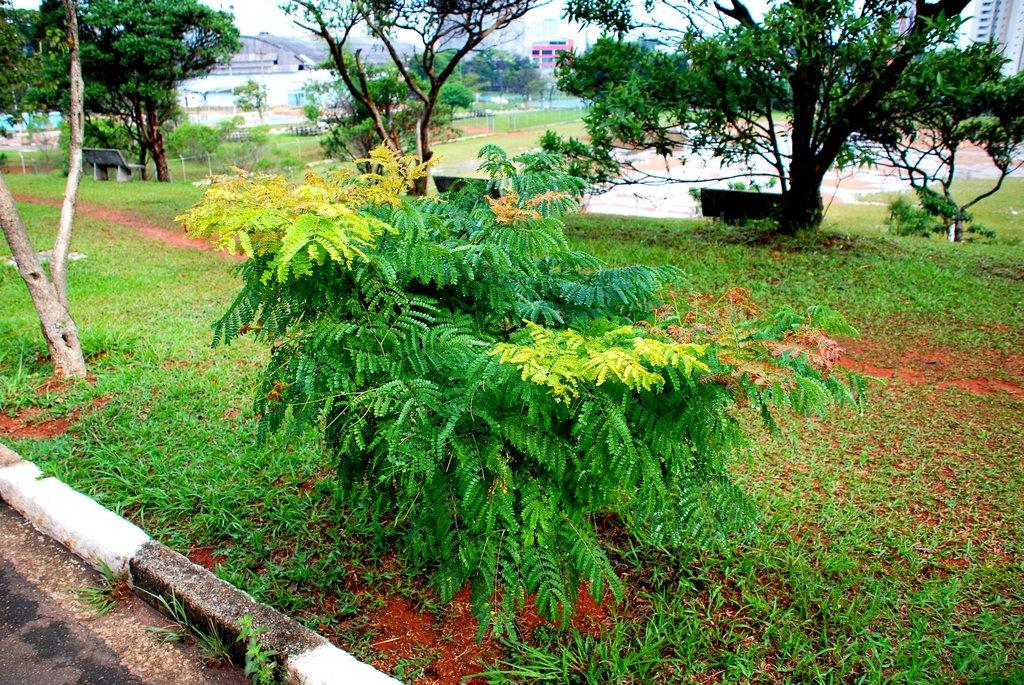Where was the picture taken? The picture was clicked outside. What can be seen in the foreground of the image? There is green grass and plants in the foreground. What is visible in the background of the image? There are benches, trees, buildings, and the sky visible in the background. What is the rate of the pump in the image? There is no pump present in the image, so it is not possible to determine its rate. 